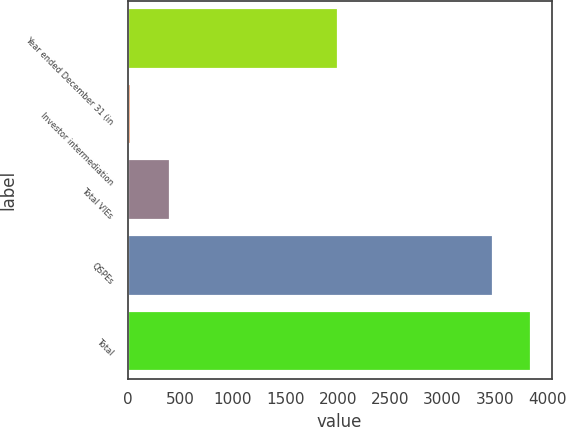Convert chart. <chart><loc_0><loc_0><loc_500><loc_500><bar_chart><fcel>Year ended December 31 (in<fcel>Investor intermediation<fcel>Total VIEs<fcel>QSPEs<fcel>Total<nl><fcel>2007<fcel>33<fcel>399.6<fcel>3479<fcel>3845.6<nl></chart> 